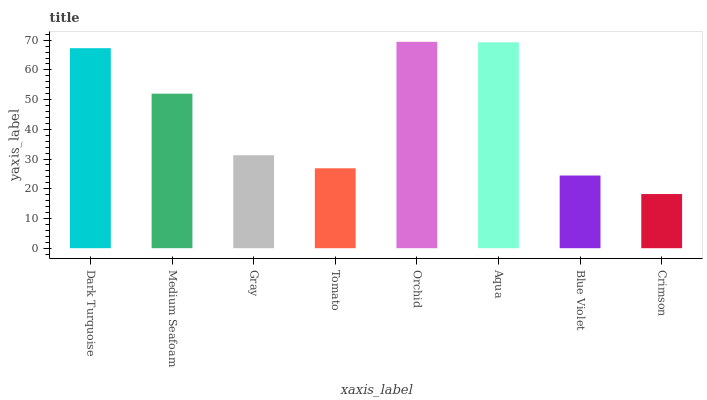Is Medium Seafoam the minimum?
Answer yes or no. No. Is Medium Seafoam the maximum?
Answer yes or no. No. Is Dark Turquoise greater than Medium Seafoam?
Answer yes or no. Yes. Is Medium Seafoam less than Dark Turquoise?
Answer yes or no. Yes. Is Medium Seafoam greater than Dark Turquoise?
Answer yes or no. No. Is Dark Turquoise less than Medium Seafoam?
Answer yes or no. No. Is Medium Seafoam the high median?
Answer yes or no. Yes. Is Gray the low median?
Answer yes or no. Yes. Is Tomato the high median?
Answer yes or no. No. Is Tomato the low median?
Answer yes or no. No. 